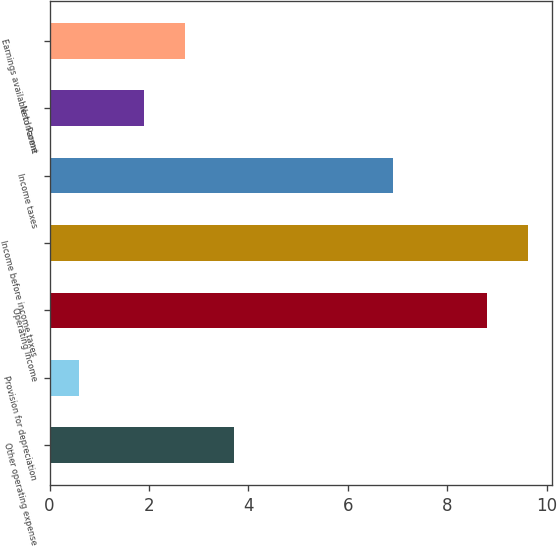Convert chart to OTSL. <chart><loc_0><loc_0><loc_500><loc_500><bar_chart><fcel>Other operating expense<fcel>Provision for depreciation<fcel>Operating Income<fcel>Income before income taxes<fcel>Income taxes<fcel>Net Income<fcel>Earnings available to Parent<nl><fcel>3.7<fcel>0.6<fcel>8.8<fcel>9.62<fcel>6.9<fcel>1.9<fcel>2.72<nl></chart> 